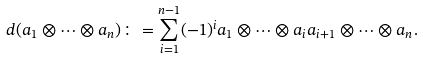<formula> <loc_0><loc_0><loc_500><loc_500>d ( a _ { 1 } \otimes \cdots \otimes a _ { n } ) \colon = \sum _ { i = 1 } ^ { n - 1 } ( - 1 ) ^ { i } a _ { 1 } \otimes \cdots \otimes a _ { i } a _ { i + 1 } \otimes \cdots \otimes a _ { n } .</formula> 